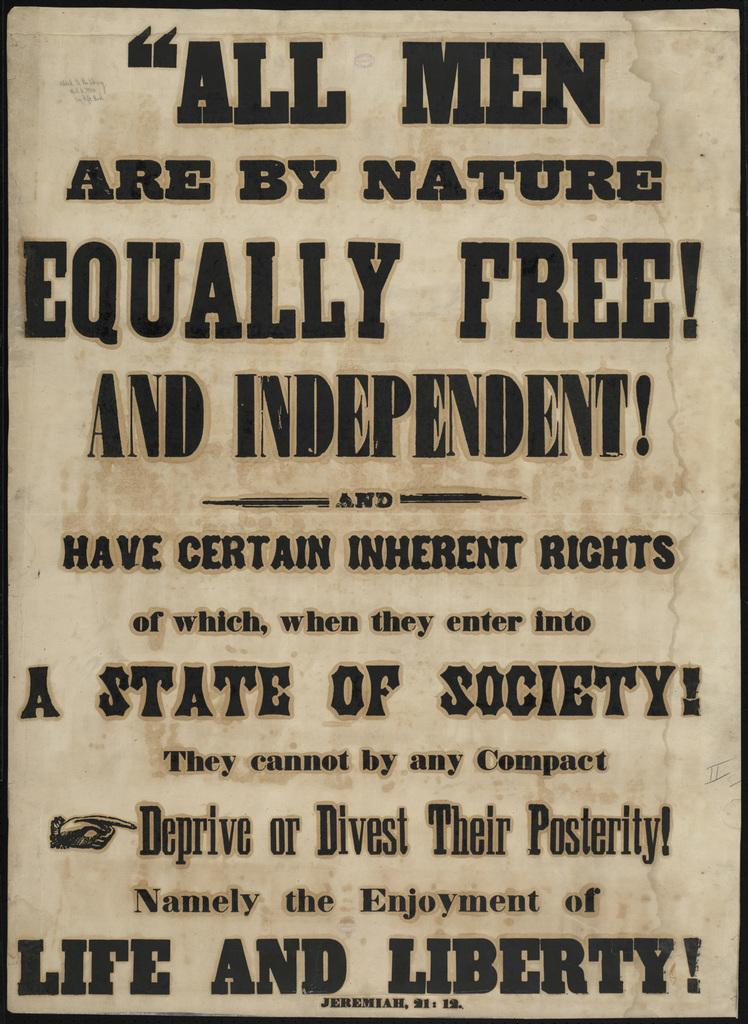<image>
Render a clear and concise summary of the photo. An old poster says that all men are by nature equally free. 